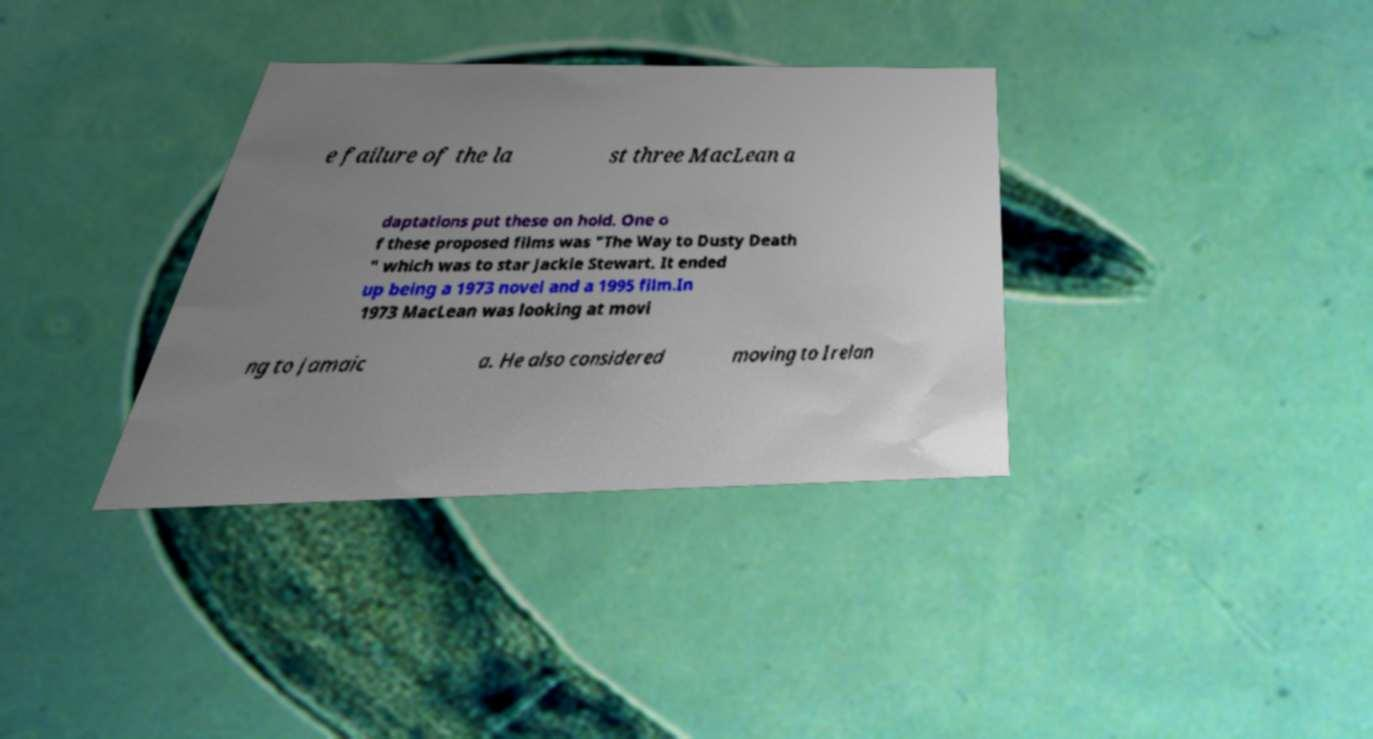I need the written content from this picture converted into text. Can you do that? e failure of the la st three MacLean a daptations put these on hold. One o f these proposed films was "The Way to Dusty Death " which was to star Jackie Stewart. It ended up being a 1973 novel and a 1995 film.In 1973 MacLean was looking at movi ng to Jamaic a. He also considered moving to Irelan 